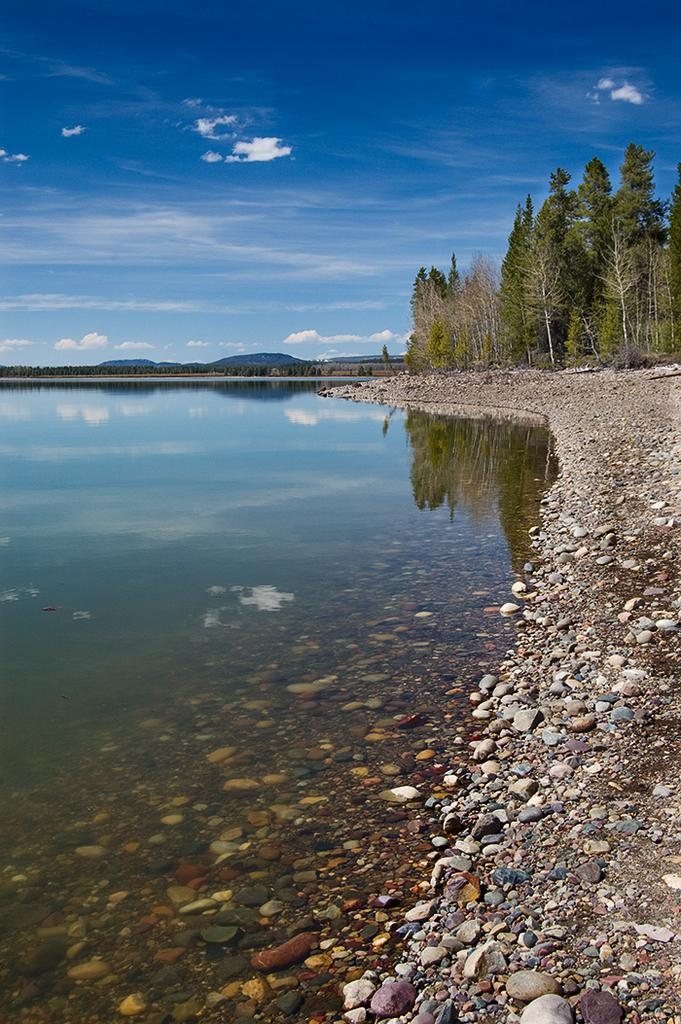What is the primary element visible in the image? There is water in the image. What other objects can be seen in the image? There are stones in the image. What can be seen in the background of the image? There are trees and mountains in the background of the image. How would you describe the sky in the image? The sky is clear in the background of the image. What type of map can be seen in the image? There is no map present in the image. What is the bit of information that the image suggests? The image does not suggest any specific bit of information; it is a visual representation of water, stones, trees, mountains, and a clear sky. 